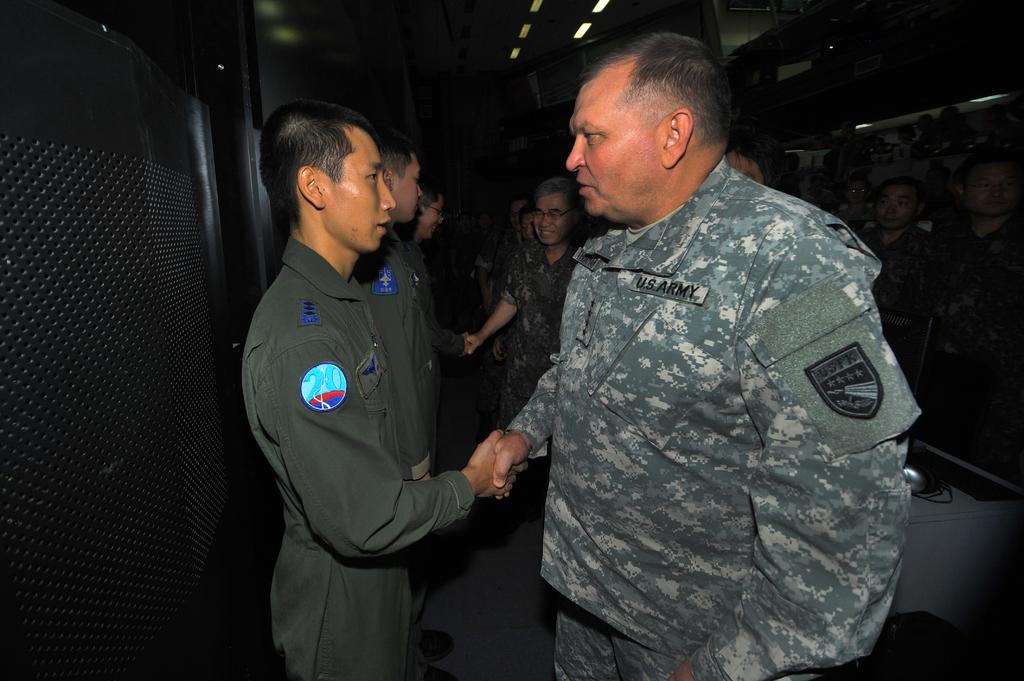What can be observed about the people in the image? There are people standing in the image, and they are wearing uniforms. What are the people doing in the image? Some people are giving each other handshakes in the image. What can be seen on the ceiling in the image? There are lights visible on the ceiling in the image. What type of discovery was made by the people in the image using a spoon? There is no spoon present in the image, and no discovery is mentioned or depicted. 